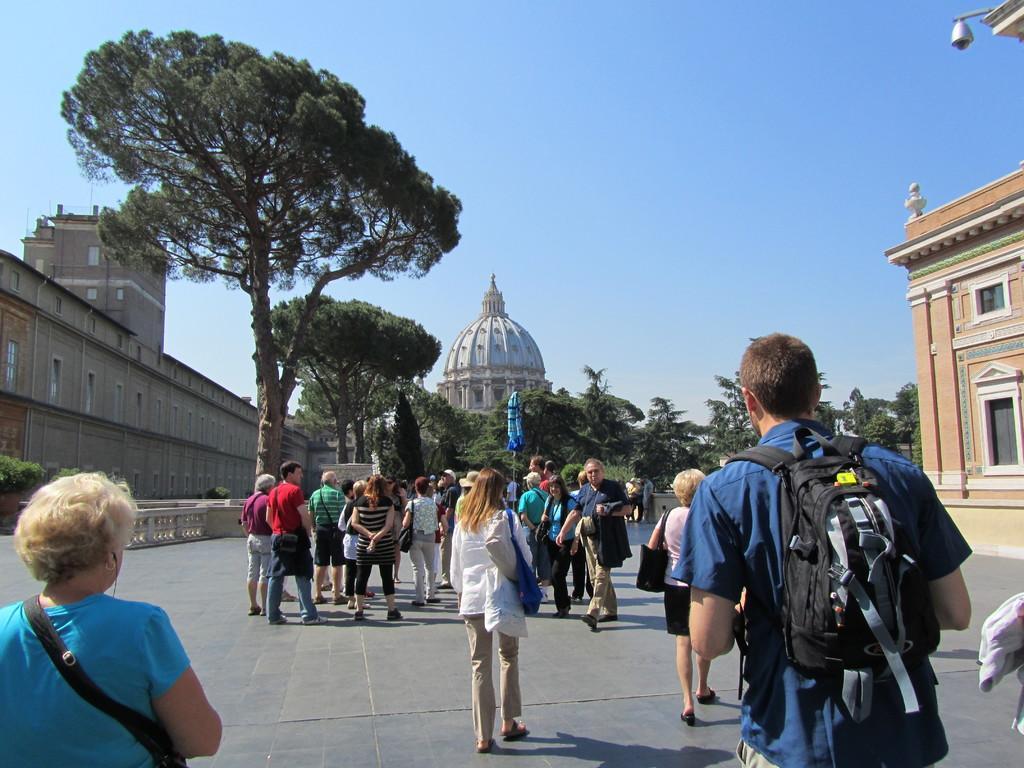Could you give a brief overview of what you see in this image? In this image, we can see persons wearing clothes. There are some trees in the middle of the image. There is a building on the left and on the right side of the image. There is a person in the bottom right of the image wearing a bag. In the background of the image, there is a sky. 